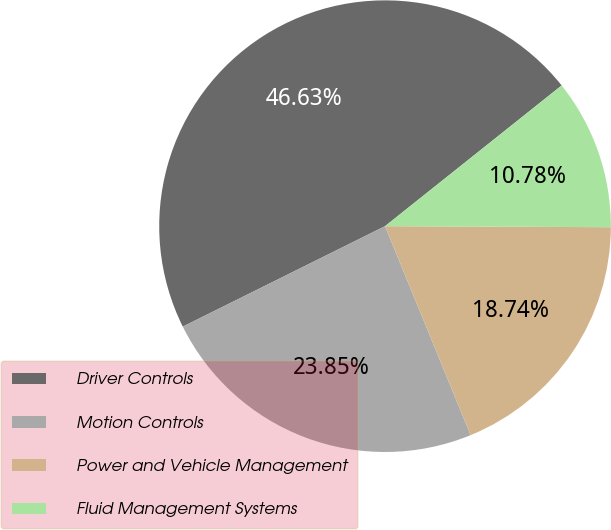<chart> <loc_0><loc_0><loc_500><loc_500><pie_chart><fcel>Driver Controls<fcel>Motion Controls<fcel>Power and Vehicle Management<fcel>Fluid Management Systems<nl><fcel>46.63%<fcel>23.85%<fcel>18.74%<fcel>10.78%<nl></chart> 